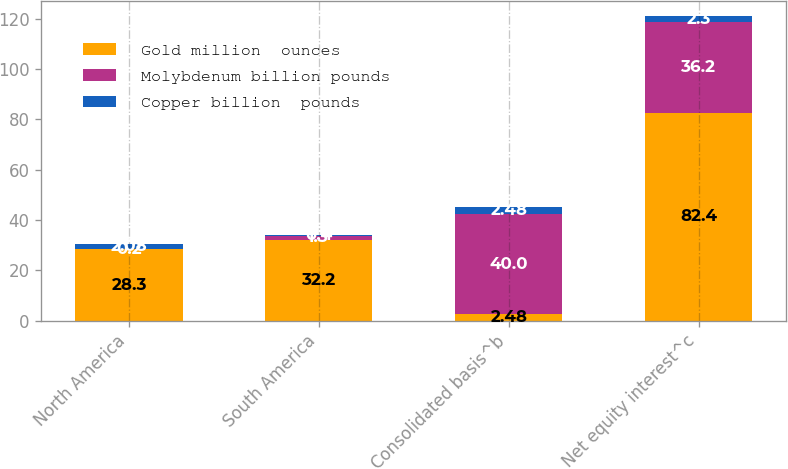Convert chart to OTSL. <chart><loc_0><loc_0><loc_500><loc_500><stacked_bar_chart><ecel><fcel>North America<fcel>South America<fcel>Consolidated basis^b<fcel>Net equity interest^c<nl><fcel>Gold million  ounces<fcel>28.3<fcel>32.2<fcel>2.48<fcel>82.4<nl><fcel>Molybdenum billion pounds<fcel>0.2<fcel>1.3<fcel>40<fcel>36.2<nl><fcel>Copper billion  pounds<fcel>2.08<fcel>0.4<fcel>2.48<fcel>2.3<nl></chart> 